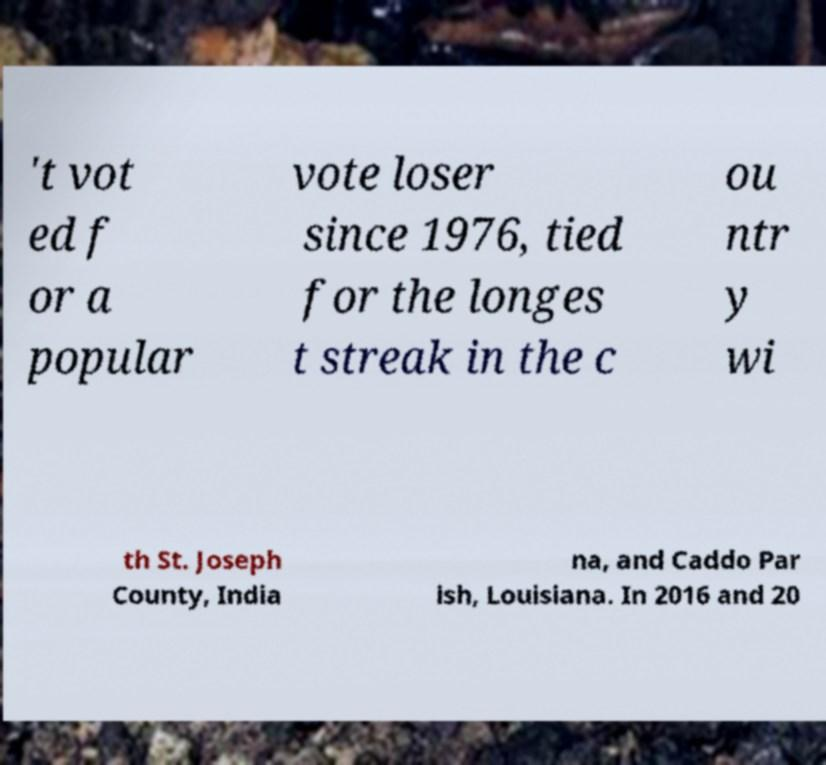Please identify and transcribe the text found in this image. 't vot ed f or a popular vote loser since 1976, tied for the longes t streak in the c ou ntr y wi th St. Joseph County, India na, and Caddo Par ish, Louisiana. In 2016 and 20 